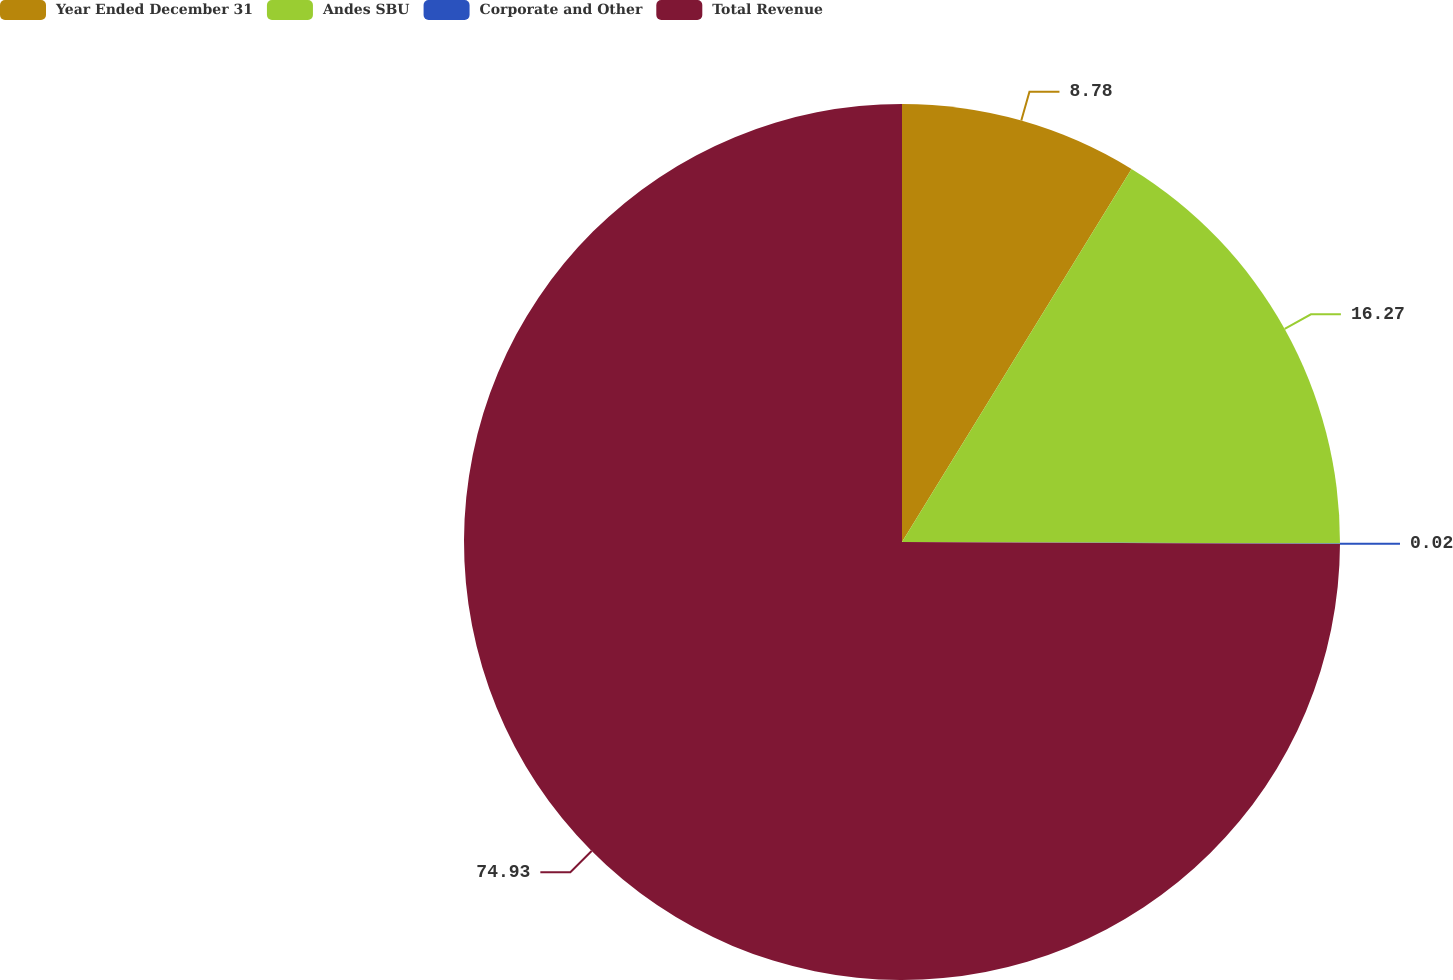Convert chart. <chart><loc_0><loc_0><loc_500><loc_500><pie_chart><fcel>Year Ended December 31<fcel>Andes SBU<fcel>Corporate and Other<fcel>Total Revenue<nl><fcel>8.78%<fcel>16.27%<fcel>0.02%<fcel>74.93%<nl></chart> 